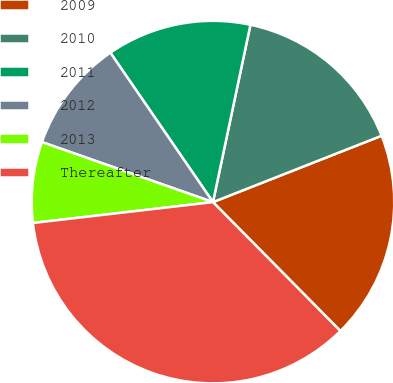Convert chart. <chart><loc_0><loc_0><loc_500><loc_500><pie_chart><fcel>2009<fcel>2010<fcel>2011<fcel>2012<fcel>2013<fcel>Thereafter<nl><fcel>18.56%<fcel>15.72%<fcel>12.89%<fcel>10.05%<fcel>7.21%<fcel>35.57%<nl></chart> 